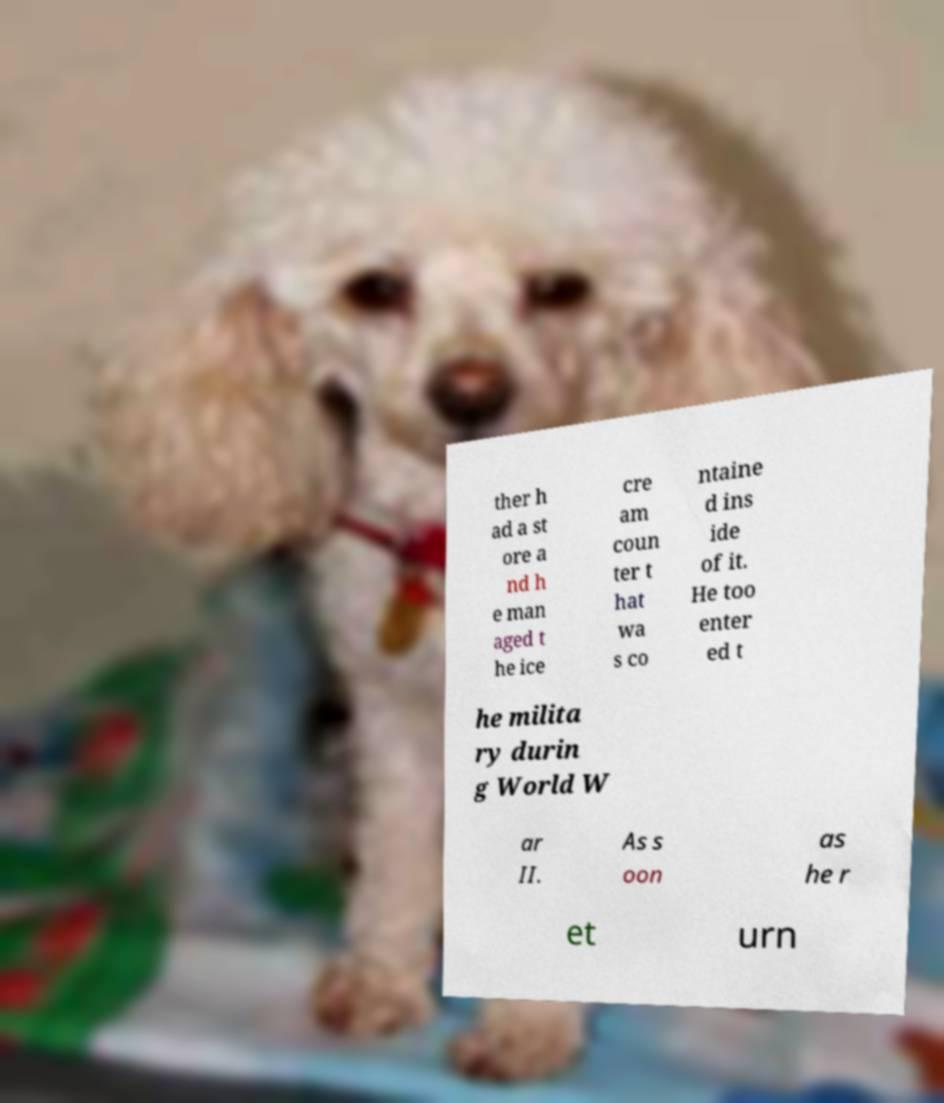Please read and relay the text visible in this image. What does it say? ther h ad a st ore a nd h e man aged t he ice cre am coun ter t hat wa s co ntaine d ins ide of it. He too enter ed t he milita ry durin g World W ar II. As s oon as he r et urn 